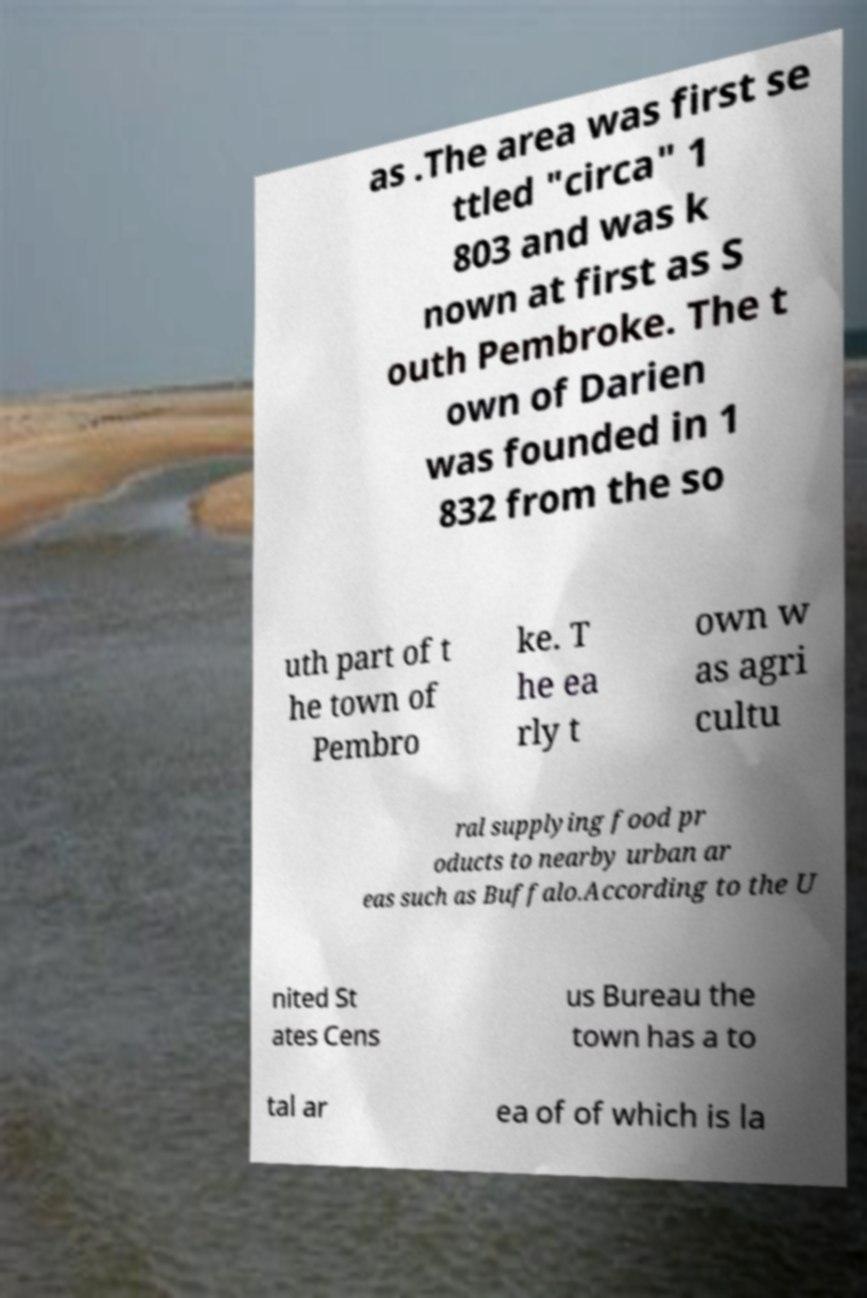There's text embedded in this image that I need extracted. Can you transcribe it verbatim? as .The area was first se ttled "circa" 1 803 and was k nown at first as S outh Pembroke. The t own of Darien was founded in 1 832 from the so uth part of t he town of Pembro ke. T he ea rly t own w as agri cultu ral supplying food pr oducts to nearby urban ar eas such as Buffalo.According to the U nited St ates Cens us Bureau the town has a to tal ar ea of of which is la 